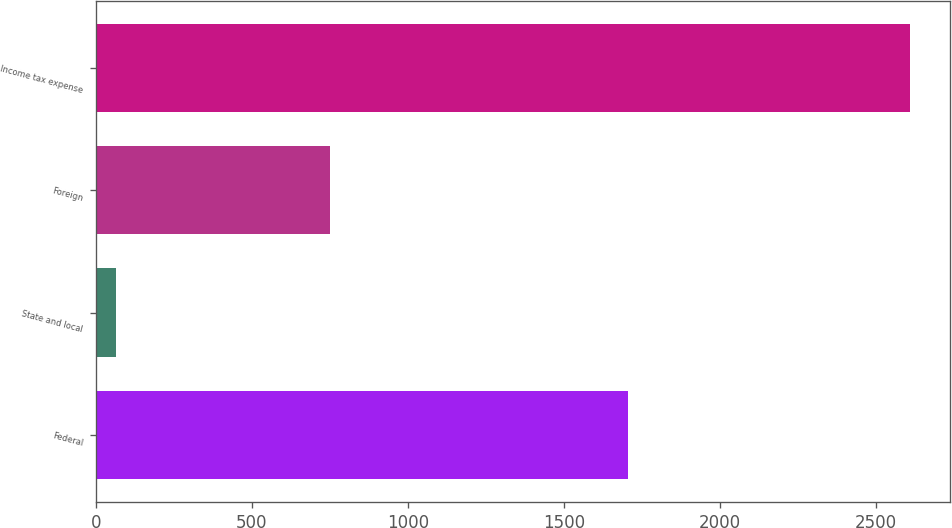Convert chart. <chart><loc_0><loc_0><loc_500><loc_500><bar_chart><fcel>Federal<fcel>State and local<fcel>Foreign<fcel>Income tax expense<nl><fcel>1704<fcel>65<fcel>752<fcel>2607<nl></chart> 